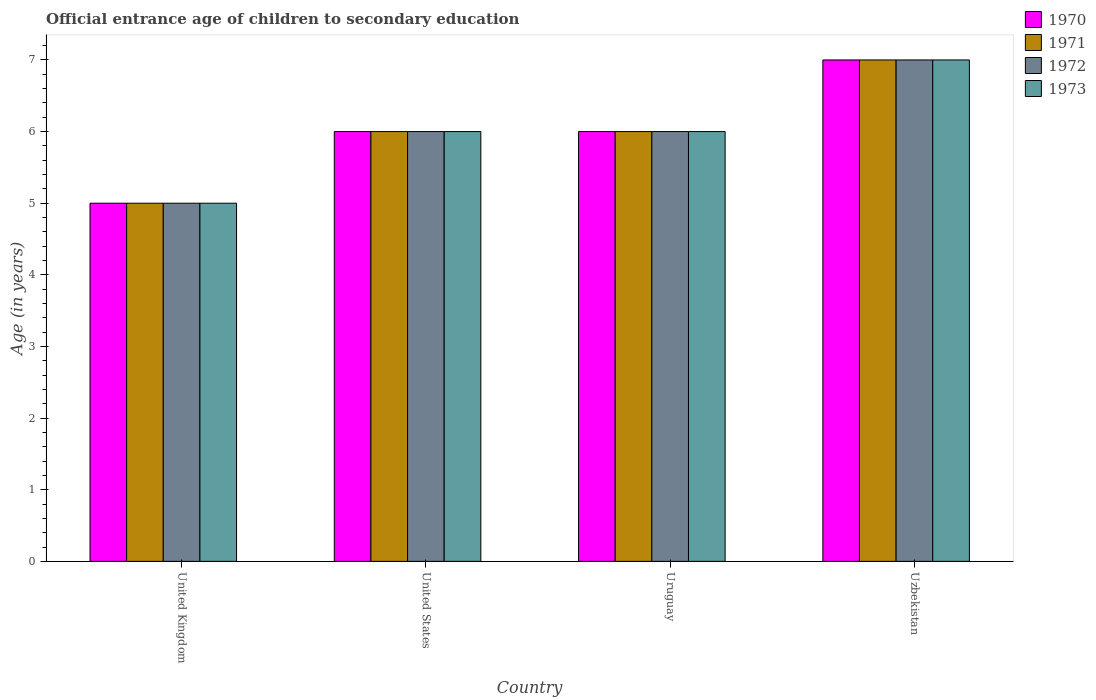How many different coloured bars are there?
Provide a short and direct response. 4. How many bars are there on the 2nd tick from the left?
Provide a short and direct response. 4. What is the label of the 1st group of bars from the left?
Your response must be concise. United Kingdom. Across all countries, what is the minimum secondary school starting age of children in 1970?
Ensure brevity in your answer.  5. In which country was the secondary school starting age of children in 1972 maximum?
Your answer should be compact. Uzbekistan. What is the difference between the secondary school starting age of children in 1973 in United States and that in Uruguay?
Keep it short and to the point. 0. What is the difference between the secondary school starting age of children in 1971 in United States and the secondary school starting age of children in 1972 in Uzbekistan?
Ensure brevity in your answer.  -1. What is the difference between the secondary school starting age of children of/in 1973 and secondary school starting age of children of/in 1972 in Uruguay?
Your answer should be very brief. 0. What is the ratio of the secondary school starting age of children in 1973 in United States to that in Uzbekistan?
Ensure brevity in your answer.  0.86. Is the difference between the secondary school starting age of children in 1973 in Uruguay and Uzbekistan greater than the difference between the secondary school starting age of children in 1972 in Uruguay and Uzbekistan?
Provide a succinct answer. No. What is the difference between the highest and the lowest secondary school starting age of children in 1970?
Give a very brief answer. 2. Is the sum of the secondary school starting age of children in 1972 in United Kingdom and United States greater than the maximum secondary school starting age of children in 1971 across all countries?
Provide a short and direct response. Yes. Is it the case that in every country, the sum of the secondary school starting age of children in 1971 and secondary school starting age of children in 1970 is greater than the sum of secondary school starting age of children in 1973 and secondary school starting age of children in 1972?
Your answer should be compact. No. Does the graph contain grids?
Give a very brief answer. No. How many legend labels are there?
Make the answer very short. 4. What is the title of the graph?
Your response must be concise. Official entrance age of children to secondary education. Does "1961" appear as one of the legend labels in the graph?
Make the answer very short. No. What is the label or title of the X-axis?
Make the answer very short. Country. What is the label or title of the Y-axis?
Give a very brief answer. Age (in years). What is the Age (in years) in 1970 in United Kingdom?
Provide a short and direct response. 5. What is the Age (in years) of 1971 in United Kingdom?
Offer a terse response. 5. What is the Age (in years) of 1972 in United Kingdom?
Make the answer very short. 5. What is the Age (in years) in 1970 in United States?
Give a very brief answer. 6. What is the Age (in years) of 1972 in United States?
Make the answer very short. 6. What is the Age (in years) of 1973 in United States?
Make the answer very short. 6. What is the Age (in years) in 1970 in Uruguay?
Keep it short and to the point. 6. What is the Age (in years) in 1971 in Uruguay?
Provide a succinct answer. 6. What is the Age (in years) of 1972 in Uruguay?
Your answer should be compact. 6. What is the Age (in years) in 1973 in Uruguay?
Offer a very short reply. 6. What is the Age (in years) of 1971 in Uzbekistan?
Offer a terse response. 7. What is the Age (in years) in 1972 in Uzbekistan?
Offer a terse response. 7. Across all countries, what is the maximum Age (in years) in 1970?
Provide a short and direct response. 7. Across all countries, what is the maximum Age (in years) in 1971?
Make the answer very short. 7. Across all countries, what is the maximum Age (in years) in 1972?
Give a very brief answer. 7. Across all countries, what is the maximum Age (in years) in 1973?
Your response must be concise. 7. What is the total Age (in years) of 1973 in the graph?
Provide a succinct answer. 24. What is the difference between the Age (in years) in 1970 in United Kingdom and that in United States?
Make the answer very short. -1. What is the difference between the Age (in years) of 1972 in United Kingdom and that in United States?
Your response must be concise. -1. What is the difference between the Age (in years) of 1971 in United Kingdom and that in Uruguay?
Offer a terse response. -1. What is the difference between the Age (in years) in 1973 in United Kingdom and that in Uruguay?
Give a very brief answer. -1. What is the difference between the Age (in years) in 1973 in United Kingdom and that in Uzbekistan?
Provide a succinct answer. -2. What is the difference between the Age (in years) of 1970 in United States and that in Uruguay?
Make the answer very short. 0. What is the difference between the Age (in years) of 1971 in United States and that in Uruguay?
Your response must be concise. 0. What is the difference between the Age (in years) of 1970 in Uruguay and that in Uzbekistan?
Ensure brevity in your answer.  -1. What is the difference between the Age (in years) of 1971 in Uruguay and that in Uzbekistan?
Your response must be concise. -1. What is the difference between the Age (in years) of 1972 in Uruguay and that in Uzbekistan?
Give a very brief answer. -1. What is the difference between the Age (in years) in 1970 in United Kingdom and the Age (in years) in 1972 in United States?
Ensure brevity in your answer.  -1. What is the difference between the Age (in years) of 1971 in United Kingdom and the Age (in years) of 1972 in United States?
Give a very brief answer. -1. What is the difference between the Age (in years) of 1970 in United Kingdom and the Age (in years) of 1972 in Uruguay?
Offer a terse response. -1. What is the difference between the Age (in years) in 1970 in United Kingdom and the Age (in years) in 1973 in Uruguay?
Give a very brief answer. -1. What is the difference between the Age (in years) in 1970 in United Kingdom and the Age (in years) in 1971 in Uzbekistan?
Ensure brevity in your answer.  -2. What is the difference between the Age (in years) in 1970 in United Kingdom and the Age (in years) in 1973 in Uzbekistan?
Ensure brevity in your answer.  -2. What is the difference between the Age (in years) of 1971 in United Kingdom and the Age (in years) of 1972 in Uzbekistan?
Give a very brief answer. -2. What is the difference between the Age (in years) in 1971 in United Kingdom and the Age (in years) in 1973 in Uzbekistan?
Ensure brevity in your answer.  -2. What is the difference between the Age (in years) of 1970 in United States and the Age (in years) of 1973 in Uruguay?
Offer a very short reply. 0. What is the difference between the Age (in years) in 1971 in United States and the Age (in years) in 1972 in Uruguay?
Provide a short and direct response. 0. What is the difference between the Age (in years) in 1971 in United States and the Age (in years) in 1973 in Uruguay?
Your answer should be very brief. 0. What is the difference between the Age (in years) in 1970 in United States and the Age (in years) in 1971 in Uzbekistan?
Provide a short and direct response. -1. What is the difference between the Age (in years) in 1970 in United States and the Age (in years) in 1972 in Uzbekistan?
Keep it short and to the point. -1. What is the difference between the Age (in years) of 1970 in United States and the Age (in years) of 1973 in Uzbekistan?
Make the answer very short. -1. What is the difference between the Age (in years) in 1971 in United States and the Age (in years) in 1972 in Uzbekistan?
Provide a succinct answer. -1. What is the difference between the Age (in years) of 1971 in United States and the Age (in years) of 1973 in Uzbekistan?
Keep it short and to the point. -1. What is the difference between the Age (in years) of 1972 in United States and the Age (in years) of 1973 in Uzbekistan?
Your answer should be compact. -1. What is the difference between the Age (in years) of 1970 in Uruguay and the Age (in years) of 1971 in Uzbekistan?
Provide a short and direct response. -1. What is the difference between the Age (in years) in 1970 in Uruguay and the Age (in years) in 1973 in Uzbekistan?
Your answer should be very brief. -1. What is the difference between the Age (in years) in 1971 in Uruguay and the Age (in years) in 1972 in Uzbekistan?
Provide a succinct answer. -1. What is the difference between the Age (in years) in 1972 in Uruguay and the Age (in years) in 1973 in Uzbekistan?
Make the answer very short. -1. What is the average Age (in years) of 1972 per country?
Your answer should be very brief. 6. What is the average Age (in years) in 1973 per country?
Your answer should be very brief. 6. What is the difference between the Age (in years) of 1970 and Age (in years) of 1971 in United Kingdom?
Ensure brevity in your answer.  0. What is the difference between the Age (in years) of 1970 and Age (in years) of 1971 in United States?
Offer a terse response. 0. What is the difference between the Age (in years) in 1971 and Age (in years) in 1972 in Uruguay?
Offer a terse response. 0. What is the difference between the Age (in years) in 1971 and Age (in years) in 1973 in Uruguay?
Provide a succinct answer. 0. What is the difference between the Age (in years) of 1972 and Age (in years) of 1973 in Uruguay?
Your response must be concise. 0. What is the difference between the Age (in years) of 1970 and Age (in years) of 1971 in Uzbekistan?
Give a very brief answer. 0. What is the difference between the Age (in years) of 1970 and Age (in years) of 1973 in Uzbekistan?
Offer a very short reply. 0. What is the difference between the Age (in years) of 1972 and Age (in years) of 1973 in Uzbekistan?
Keep it short and to the point. 0. What is the ratio of the Age (in years) of 1970 in United Kingdom to that in United States?
Give a very brief answer. 0.83. What is the ratio of the Age (in years) of 1972 in United Kingdom to that in United States?
Offer a very short reply. 0.83. What is the ratio of the Age (in years) of 1973 in United Kingdom to that in United States?
Your answer should be very brief. 0.83. What is the ratio of the Age (in years) in 1971 in United Kingdom to that in Uruguay?
Keep it short and to the point. 0.83. What is the ratio of the Age (in years) in 1972 in United Kingdom to that in Uruguay?
Your answer should be compact. 0.83. What is the ratio of the Age (in years) of 1970 in United Kingdom to that in Uzbekistan?
Make the answer very short. 0.71. What is the ratio of the Age (in years) of 1971 in United Kingdom to that in Uzbekistan?
Provide a short and direct response. 0.71. What is the ratio of the Age (in years) of 1972 in United Kingdom to that in Uzbekistan?
Your response must be concise. 0.71. What is the ratio of the Age (in years) in 1973 in United Kingdom to that in Uzbekistan?
Offer a very short reply. 0.71. What is the ratio of the Age (in years) in 1970 in United States to that in Uruguay?
Offer a terse response. 1. What is the ratio of the Age (in years) in 1972 in United States to that in Uruguay?
Ensure brevity in your answer.  1. What is the ratio of the Age (in years) in 1973 in United States to that in Uruguay?
Offer a very short reply. 1. What is the ratio of the Age (in years) of 1971 in United States to that in Uzbekistan?
Provide a short and direct response. 0.86. What is the ratio of the Age (in years) in 1972 in United States to that in Uzbekistan?
Your answer should be compact. 0.86. What is the ratio of the Age (in years) of 1970 in Uruguay to that in Uzbekistan?
Offer a terse response. 0.86. What is the ratio of the Age (in years) of 1971 in Uruguay to that in Uzbekistan?
Ensure brevity in your answer.  0.86. What is the ratio of the Age (in years) in 1973 in Uruguay to that in Uzbekistan?
Keep it short and to the point. 0.86. What is the difference between the highest and the second highest Age (in years) of 1972?
Offer a terse response. 1. What is the difference between the highest and the second highest Age (in years) of 1973?
Offer a terse response. 1. What is the difference between the highest and the lowest Age (in years) in 1973?
Your answer should be very brief. 2. 